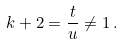Convert formula to latex. <formula><loc_0><loc_0><loc_500><loc_500>k + 2 = \frac { t } { u } \neq 1 \, .</formula> 